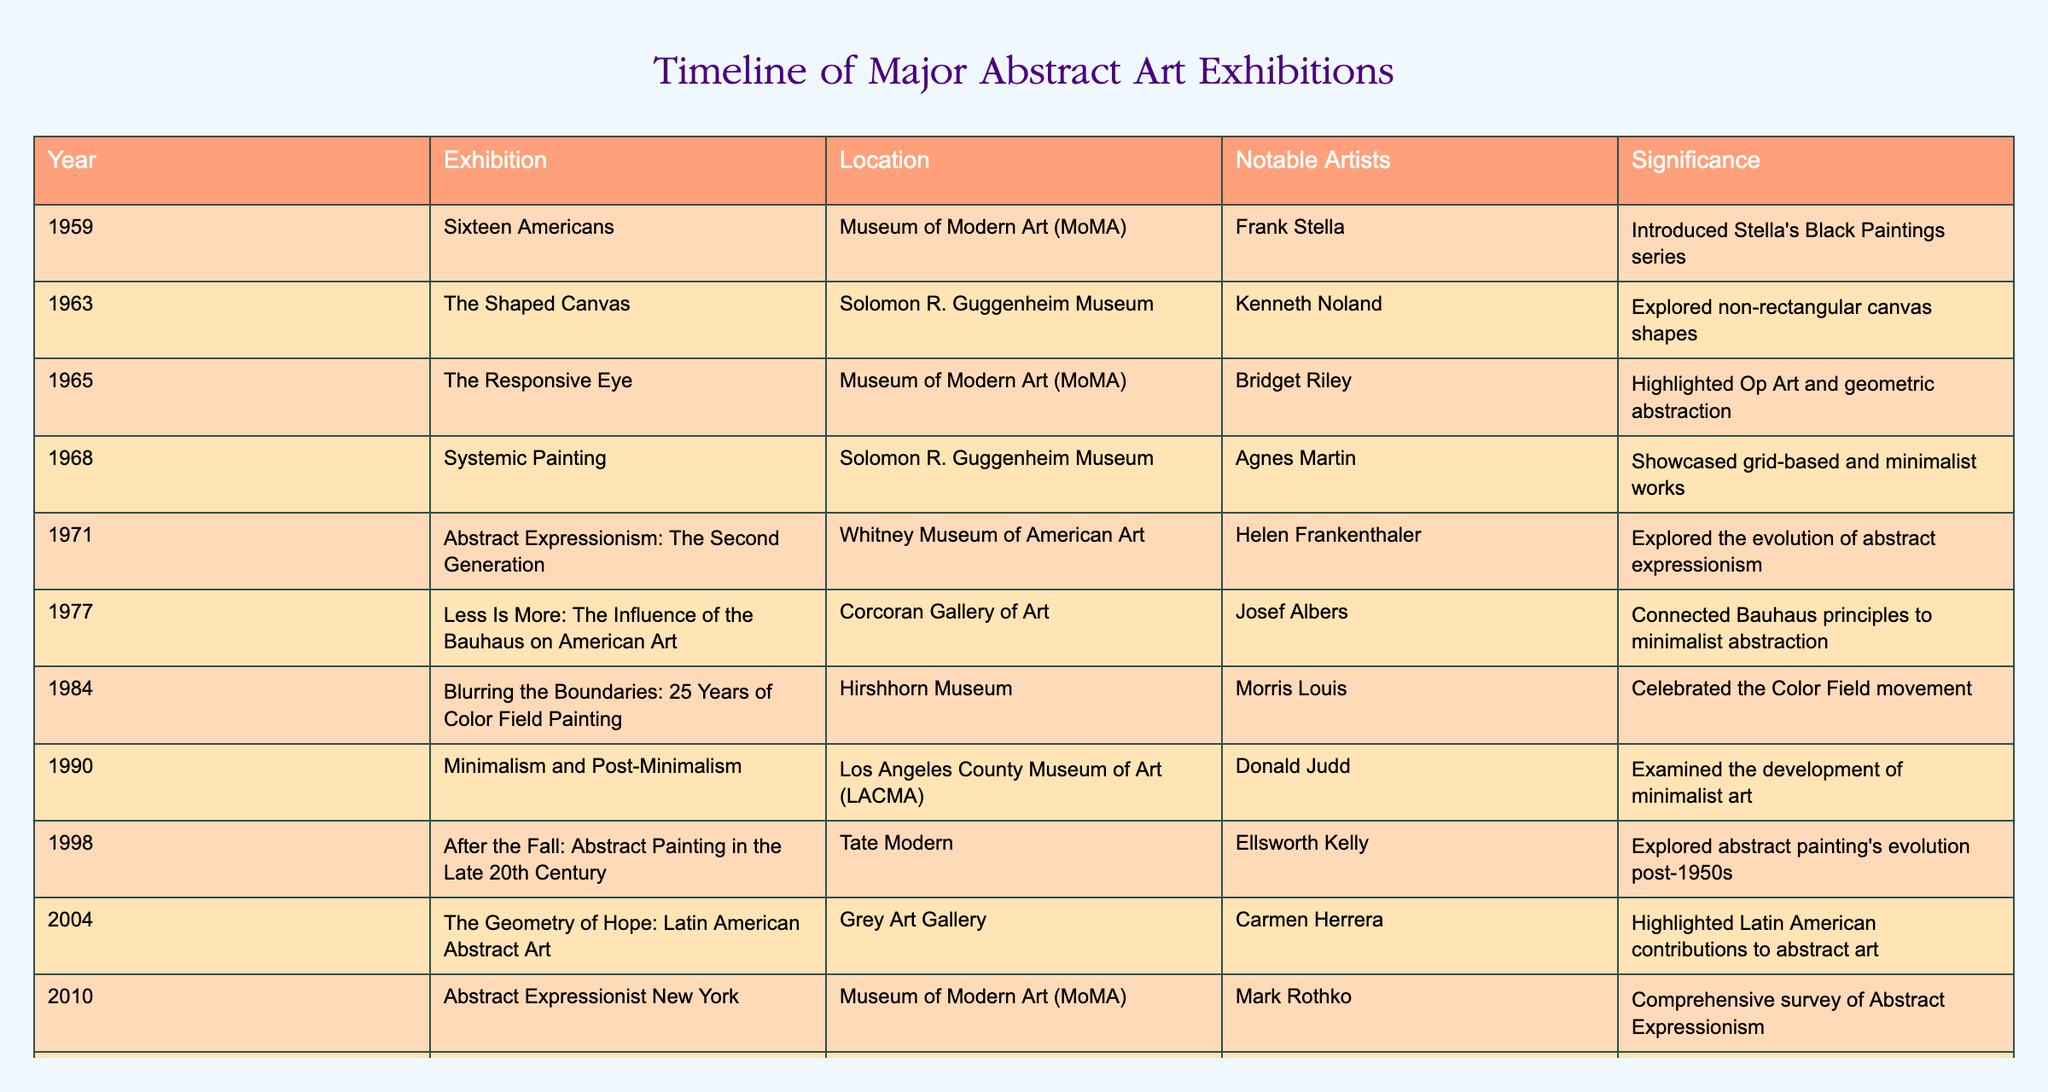What year did the exhibition "The Responsive Eye" take place? The table lists the exhibition "The Responsive Eye" under the year column, which shows it occurred in 1965.
Answer: 1965 Which exhibition featured the artist Joseph Albers? According to the table, the exhibition titled "Less Is More: The Influence of the Bauhaus on American Art" at the Corcoran Gallery of Art featured Josef Albers.
Answer: Less Is More: The Influence of the Bauhaus on American Art How many exhibitions took place in the 1970s? By counting the entries from 1970 to 1979 in the year column, there are three exhibitions listed: "Abstract Expressionism: The Second Generation" in 1971, "Less Is More" in 1977, and "Blurring the Boundaries" in 1984. The count leads to 3 exhibitions.
Answer: 3 What is the significance of the exhibition "Shape of Light: 100 Years of Photography and Abstract Art"? The significance column notes that this exhibition explored the relationship between abstract art and photography, indicating a thematic connection that celebrates both mediums.
Answer: Explored the relationship between abstract art and photography Which exhibition had the most notable artists listed? Scanning the notable artists column, the exhibition "Minimalism and Post-Minimalism" in 1990 includes Donald Judd as a significant contributor among entries, whereas other exhibitions have fewer or single notable artists, indicating it as the most notable.
Answer: Minimalism and Post-Minimalism In what year did the exhibition "After the Fall: Abstract Painting in the Late 20th Century" occur? The table clearly states that this exhibition took place in 1998, as listed under the year column.
Answer: 1998 Was the exhibition "The Shaped Canvas" significant for non-rectangular canvas shapes? Yes, the table specifies that this exhibition explored non-rectangular canvas shapes, confirming its significance in this context.
Answer: Yes How many years apart were "Adventures of the Black Square" and "Rhythm and Geometry"? The exhibition "Adventures of the Black Square" was in 2015, and "Rhythm and Geometry" occurred in 2021. The difference in years is 2021 - 2015 = 6 years.
Answer: 6 years Which of the listed exhibitions emphasized the role of Constructivism in British abstract art? According to the table, the exhibition titled "Rhythm and Geometry: Constructivist art in Britain since 1951" specifically examines the legacy of Constructivism in British abstract art as noted in the significance column.
Answer: Rhythm and Geometry: Constructivist art in Britain since 1951 